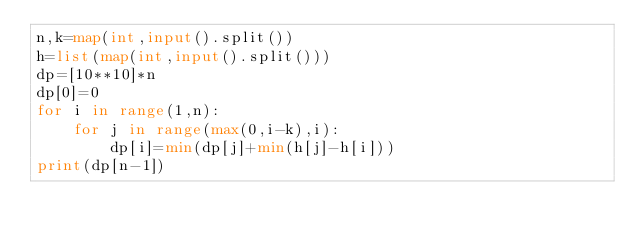Convert code to text. <code><loc_0><loc_0><loc_500><loc_500><_Python_>n,k=map(int,input().split())
h=list(map(int,input().split()))
dp=[10**10]*n
dp[0]=0
for i in range(1,n):
    for j in range(max(0,i-k),i):
        dp[i]=min(dp[j]+min(h[j]-h[i]))
print(dp[n-1])
</code> 